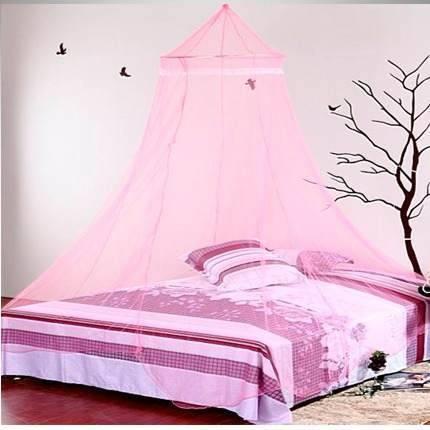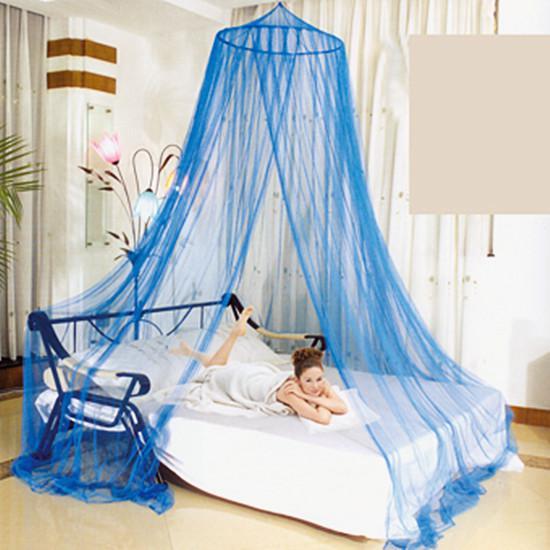The first image is the image on the left, the second image is the image on the right. Evaluate the accuracy of this statement regarding the images: "One of the images of mosquito nets has a round top with silver flowers on it.". Is it true? Answer yes or no. No. The first image is the image on the left, the second image is the image on the right. For the images shown, is this caption "The style and shape of bed netting is the same in both images." true? Answer yes or no. Yes. 